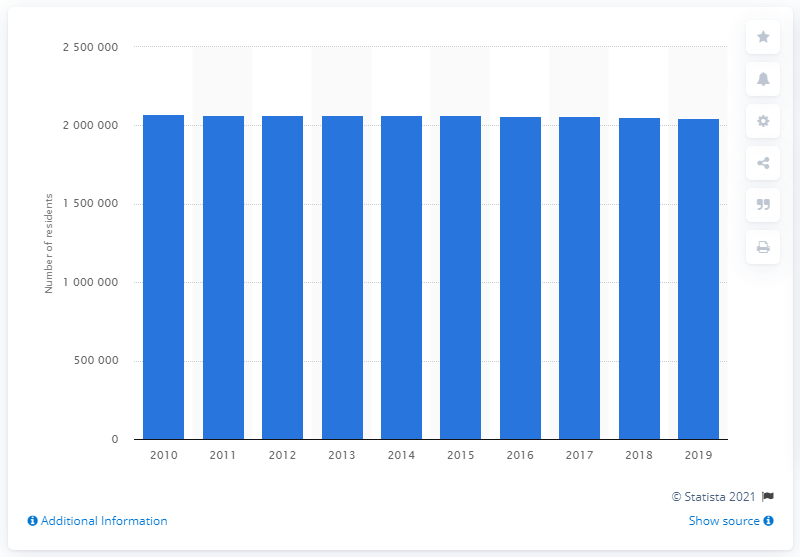Highlight a few significant elements in this photo. In 2019, the Cleveland-Elyria metropolitan area was home to approximately 2,068,989 people. 